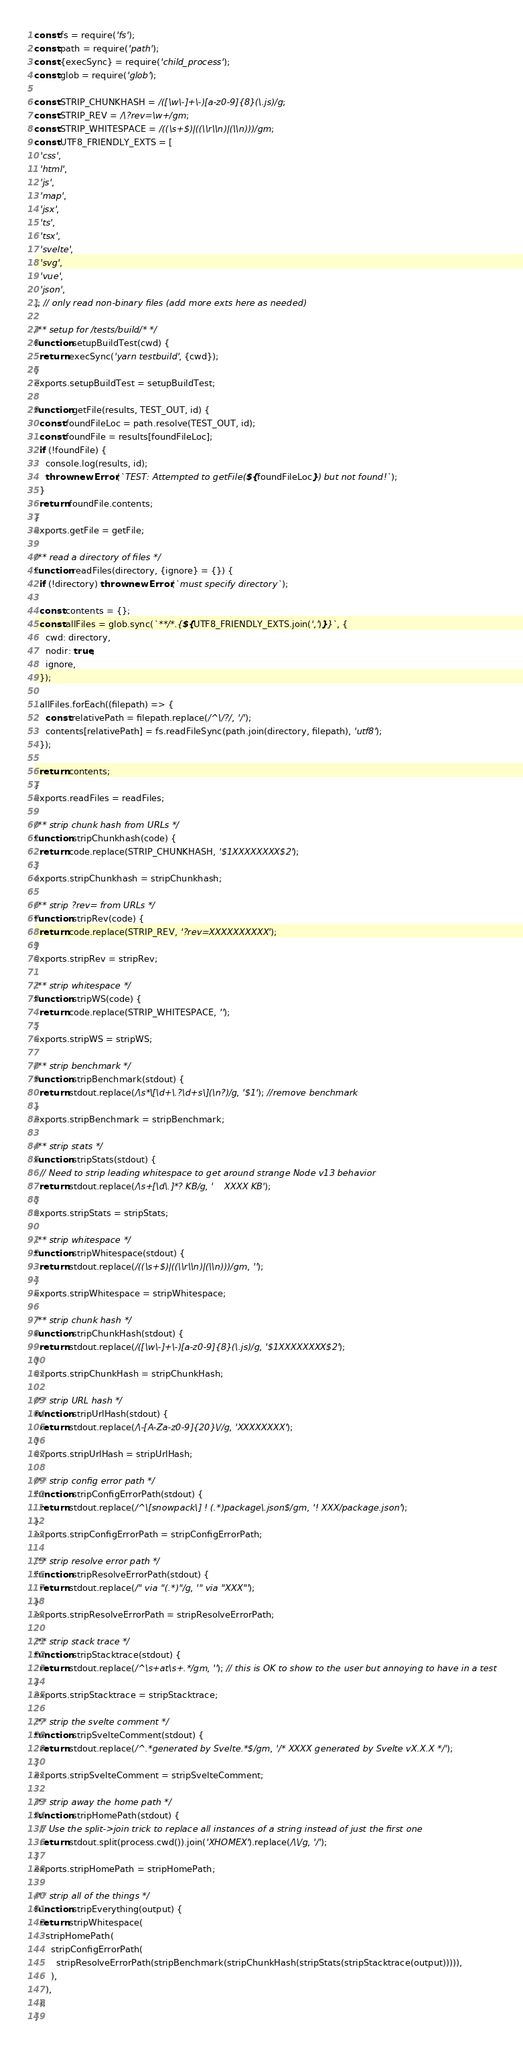Convert code to text. <code><loc_0><loc_0><loc_500><loc_500><_JavaScript_>const fs = require('fs');
const path = require('path');
const {execSync} = require('child_process');
const glob = require('glob');

const STRIP_CHUNKHASH = /([\w\-]+\-)[a-z0-9]{8}(\.js)/g;
const STRIP_REV = /\?rev=\w+/gm;
const STRIP_WHITESPACE = /((\s+$)|((\\r\\n)|(\\n)))/gm;
const UTF8_FRIENDLY_EXTS = [
  'css',
  'html',
  'js',
  'map',
  'jsx',
  'ts',
  'tsx',
  'svelte',
  'svg',
  'vue',
  'json',
]; // only read non-binary files (add more exts here as needed)

/** setup for /tests/build/* */
function setupBuildTest(cwd) {
  return execSync('yarn testbuild', {cwd});
}
exports.setupBuildTest = setupBuildTest;

function getFile(results, TEST_OUT, id) {
  const foundFileLoc = path.resolve(TEST_OUT, id);
  const foundFile = results[foundFileLoc];
  if (!foundFile) {
    console.log(results, id);
    throw new Error(`TEST: Attempted to getFile(${foundFileLoc}) but not found!`);
  }
  return foundFile.contents;
}
exports.getFile = getFile;

/** read a directory of files */
function readFiles(directory, {ignore} = {}) {
  if (!directory) throw new Error(`must specify directory`);

  const contents = {};
  const allFiles = glob.sync(`**/*.{${UTF8_FRIENDLY_EXTS.join(',')}}`, {
    cwd: directory,
    nodir: true,
    ignore,
  });

  allFiles.forEach((filepath) => {
    const relativePath = filepath.replace(/^\/?/, '/');
    contents[relativePath] = fs.readFileSync(path.join(directory, filepath), 'utf8');
  });

  return contents;
}
exports.readFiles = readFiles;

/** strip chunk hash from URLs */
function stripChunkhash(code) {
  return code.replace(STRIP_CHUNKHASH, '$1XXXXXXXX$2');
}
exports.stripChunkhash = stripChunkhash;

/** strip ?rev= from URLs */
function stripRev(code) {
  return code.replace(STRIP_REV, '?rev=XXXXXXXXXX');
}
exports.stripRev = stripRev;

/** strip whitespace */
function stripWS(code) {
  return code.replace(STRIP_WHITESPACE, '');
}
exports.stripWS = stripWS;

/** strip benchmark */
function stripBenchmark(stdout) {
  return stdout.replace(/\s*\[\d+\.?\d+s\](\n?)/g, '$1'); //remove benchmark
}
exports.stripBenchmark = stripBenchmark;

/** strip stats */
function stripStats(stdout) {
  // Need to strip leading whitespace to get around strange Node v13 behavior
  return stdout.replace(/\s+[\d\.]*? KB/g, '    XXXX KB');
}
exports.stripStats = stripStats;

/** strip whitespace */
function stripWhitespace(stdout) {
  return stdout.replace(/((\s+$)|((\\r\\n)|(\\n)))/gm, '');
}
exports.stripWhitespace = stripWhitespace;

/** strip chunk hash */
function stripChunkHash(stdout) {
  return stdout.replace(/([\w\-]+\-)[a-z0-9]{8}(\.js)/g, '$1XXXXXXXX$2');
}
exports.stripChunkHash = stripChunkHash;

/** strip URL hash */
function stripUrlHash(stdout) {
  return stdout.replace(/\-[A-Za-z0-9]{20}\//g, 'XXXXXXXX');
}
exports.stripUrlHash = stripUrlHash;

/** strip config error path */
function stripConfigErrorPath(stdout) {
  return stdout.replace(/^\[snowpack\] ! (.*)package\.json$/gm, '! XXX/package.json');
}
exports.stripConfigErrorPath = stripConfigErrorPath;

/** strip resolve error path */
function stripResolveErrorPath(stdout) {
  return stdout.replace(/" via "(.*)"/g, '" via "XXX"');
}
exports.stripResolveErrorPath = stripResolveErrorPath;

/** strip stack trace */
function stripStacktrace(stdout) {
  return stdout.replace(/^\s+at\s+.*/gm, ''); // this is OK to show to the user but annoying to have in a test
}
exports.stripStacktrace = stripStacktrace;

/** strip the svelte comment */
function stripSvelteComment(stdout) {
  return stdout.replace(/^.*generated by Svelte.*$/gm, '/* XXXX generated by Svelte vX.X.X */');
}
exports.stripSvelteComment = stripSvelteComment;

/** strip away the home path */
function stripHomePath(stdout) {
  // Use the split->join trick to replace all instances of a string instead of just the first one
  return stdout.split(process.cwd()).join('XHOMEX').replace(/\\/g, '/');
}
exports.stripHomePath = stripHomePath;

/** strip all of the things */
function stripEverything(output) {
  return stripWhitespace(
    stripHomePath(
      stripConfigErrorPath(
        stripResolveErrorPath(stripBenchmark(stripChunkHash(stripStats(stripStacktrace(output))))),
      ),
    ),
  );
}</code> 